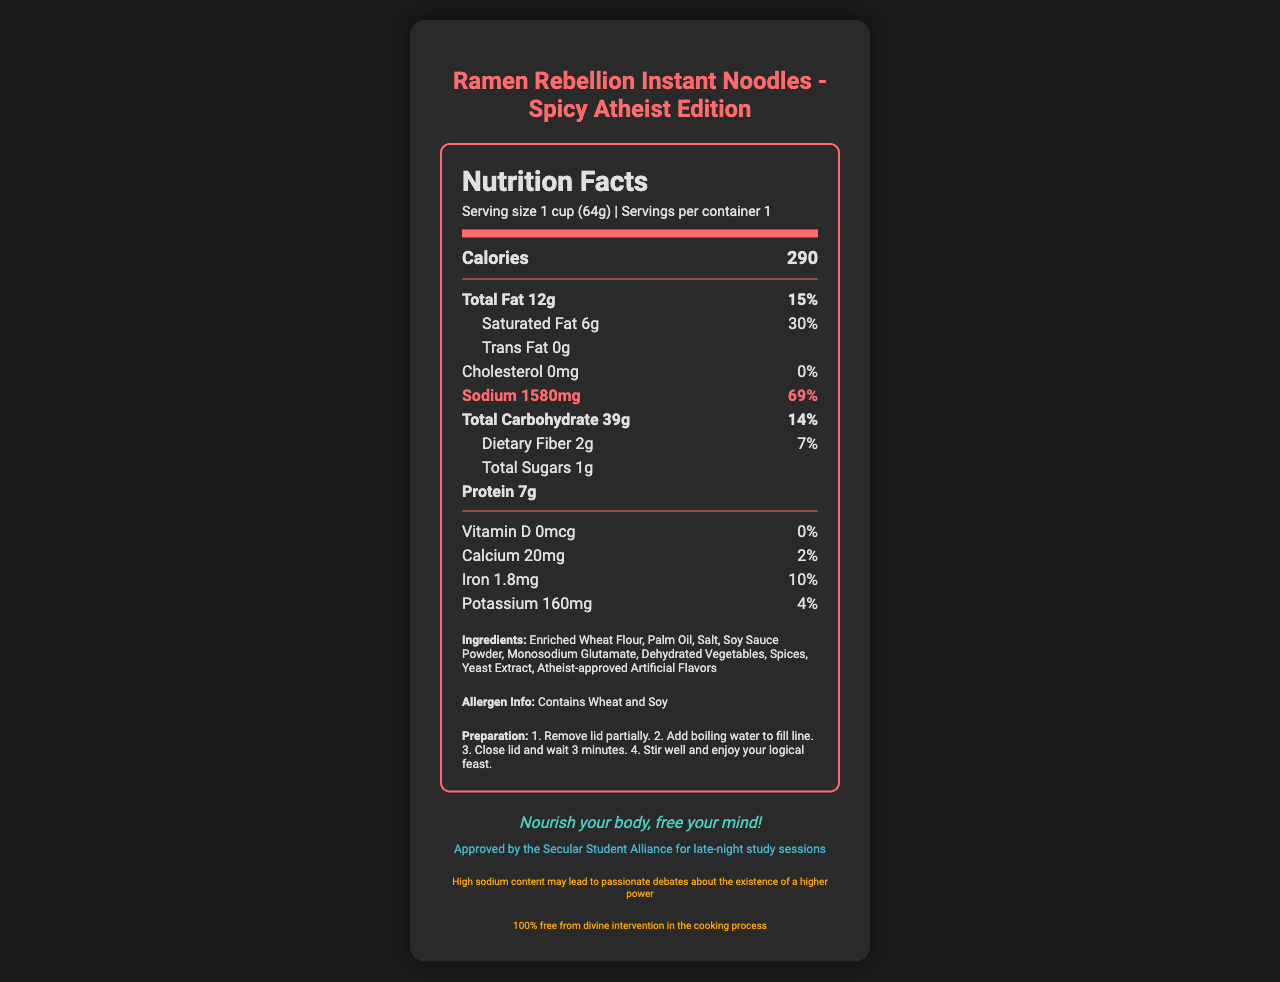what is the sodium amount in the ramen cup? The document states that the sodium amount is 1580 mg.
Answer: 1580 mg how many calories are in a serving? The document indicates that each serving contains 290 calories.
Answer: 290 what is the percentage daily value for sodium? The percentage daily value for sodium is 69%, as highlighted in the document.
Answer: 69% how much protein does the ramen cup contain? The nutrition label indicates that the ramen cup contains 7 grams of protein.
Answer: 7g what is the serving size for the ramen cup? The serving size is listed as 1 cup (64g) on the document.
Answer: 1 cup (64g) how much dietary fiber is in the ramen cup? The nutrition facts label notes that there is 2 grams of dietary fiber.
Answer: 2g which ingredient is listed first? The first ingredient listed is Enriched Wheat Flour.
Answer: Enriched Wheat Flour what does the sodium disclaimer mention? The sodium disclaimer states: "High sodium content may lead to passionate debates about the existence of a higher power."
Answer: High sodium content may lead to passionate debates about the existence of a higher power what is the product name? The product name is given as "Ramen Rebellion Instant Noodles - Spicy Atheist Edition."
Answer: Ramen Rebellion Instant Noodles - Spicy Atheist Edition how many servings per container? The document specifies that there is 1 serving per container.
Answer: 1 what is the preparation method? The preparation steps are clearly listed on the document.
Answer: 1. Remove lid partially. 2. Add boiling water to fill line. 3. Close lid and wait 3 minutes. 4. Stir well and enjoy your logical feast. what is the total fat content and its daily value? A. 10g, 12% B. 12g, 15% C. 14g, 18% D. 16g, 20% The document states that the total fat content is 12g, with a daily value of 15%.
Answer: B how much iron is in the cup? A. 0.5mg B. 1.0mg C. 1.8mg D. 2.0mg The iron content is listed as 1.8mg.
Answer: C does the ramen cup contain any cholesterol? The nutrition facts indicate that the ramen cup contains 0 mg of cholesterol, which corresponds to 0% of the daily value.
Answer: No is there any trans fat in this product? The document indicates that the trans fat amount is 0 grams.
Answer: No what are the main highlights of the document? The summary includes the product name, key nutritional details, ingredients, allergen information, preparation steps, and endorsements, focusing on the product's unique 'atheist' branding and high sodium content.
Answer: The document provides a detailed nutrition facts label for "Ramen Rebellion Instant Noodles - Spicy Atheist Edition," highlighting key nutritional values such as 290 calories, 12g of total fat, 1580mg of sodium (69% daily value), and 7g of protein. It also mentions the product's ingredients, allergen information, preparation steps, and endorsements from the Secular Student Alliance. what is the exact amount of each spice in the product? The document lists "Spices" as an ingredient but does not provide detailed amounts for each type of spice.
Answer: Not enough information 